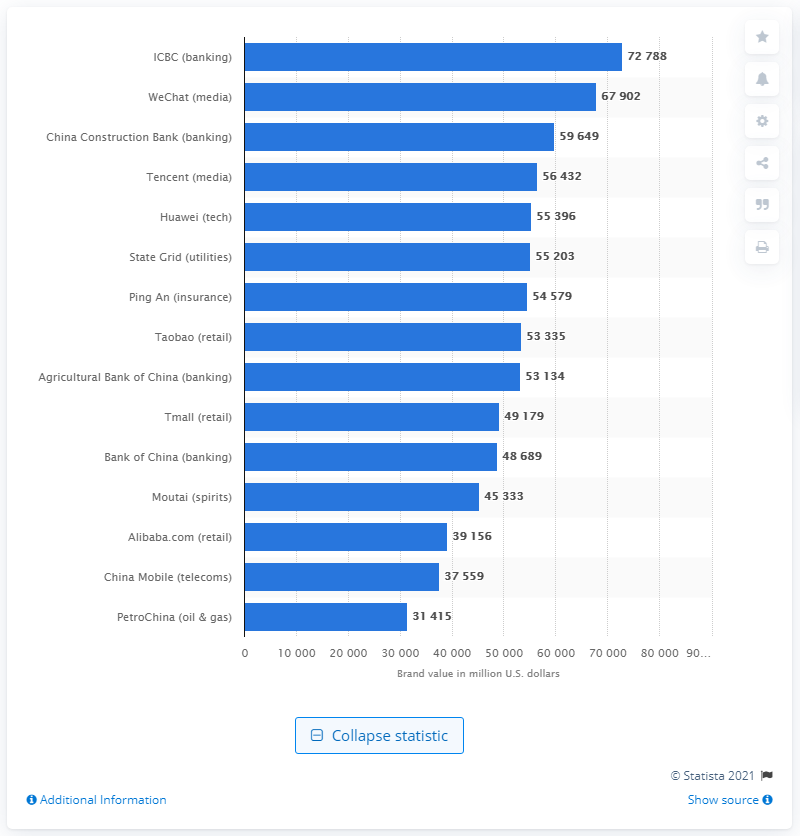Identify some key points in this picture. In 2021, the brand value of Industrial and Commercial Bank of China was approximately 72,788 U.S. dollars. 